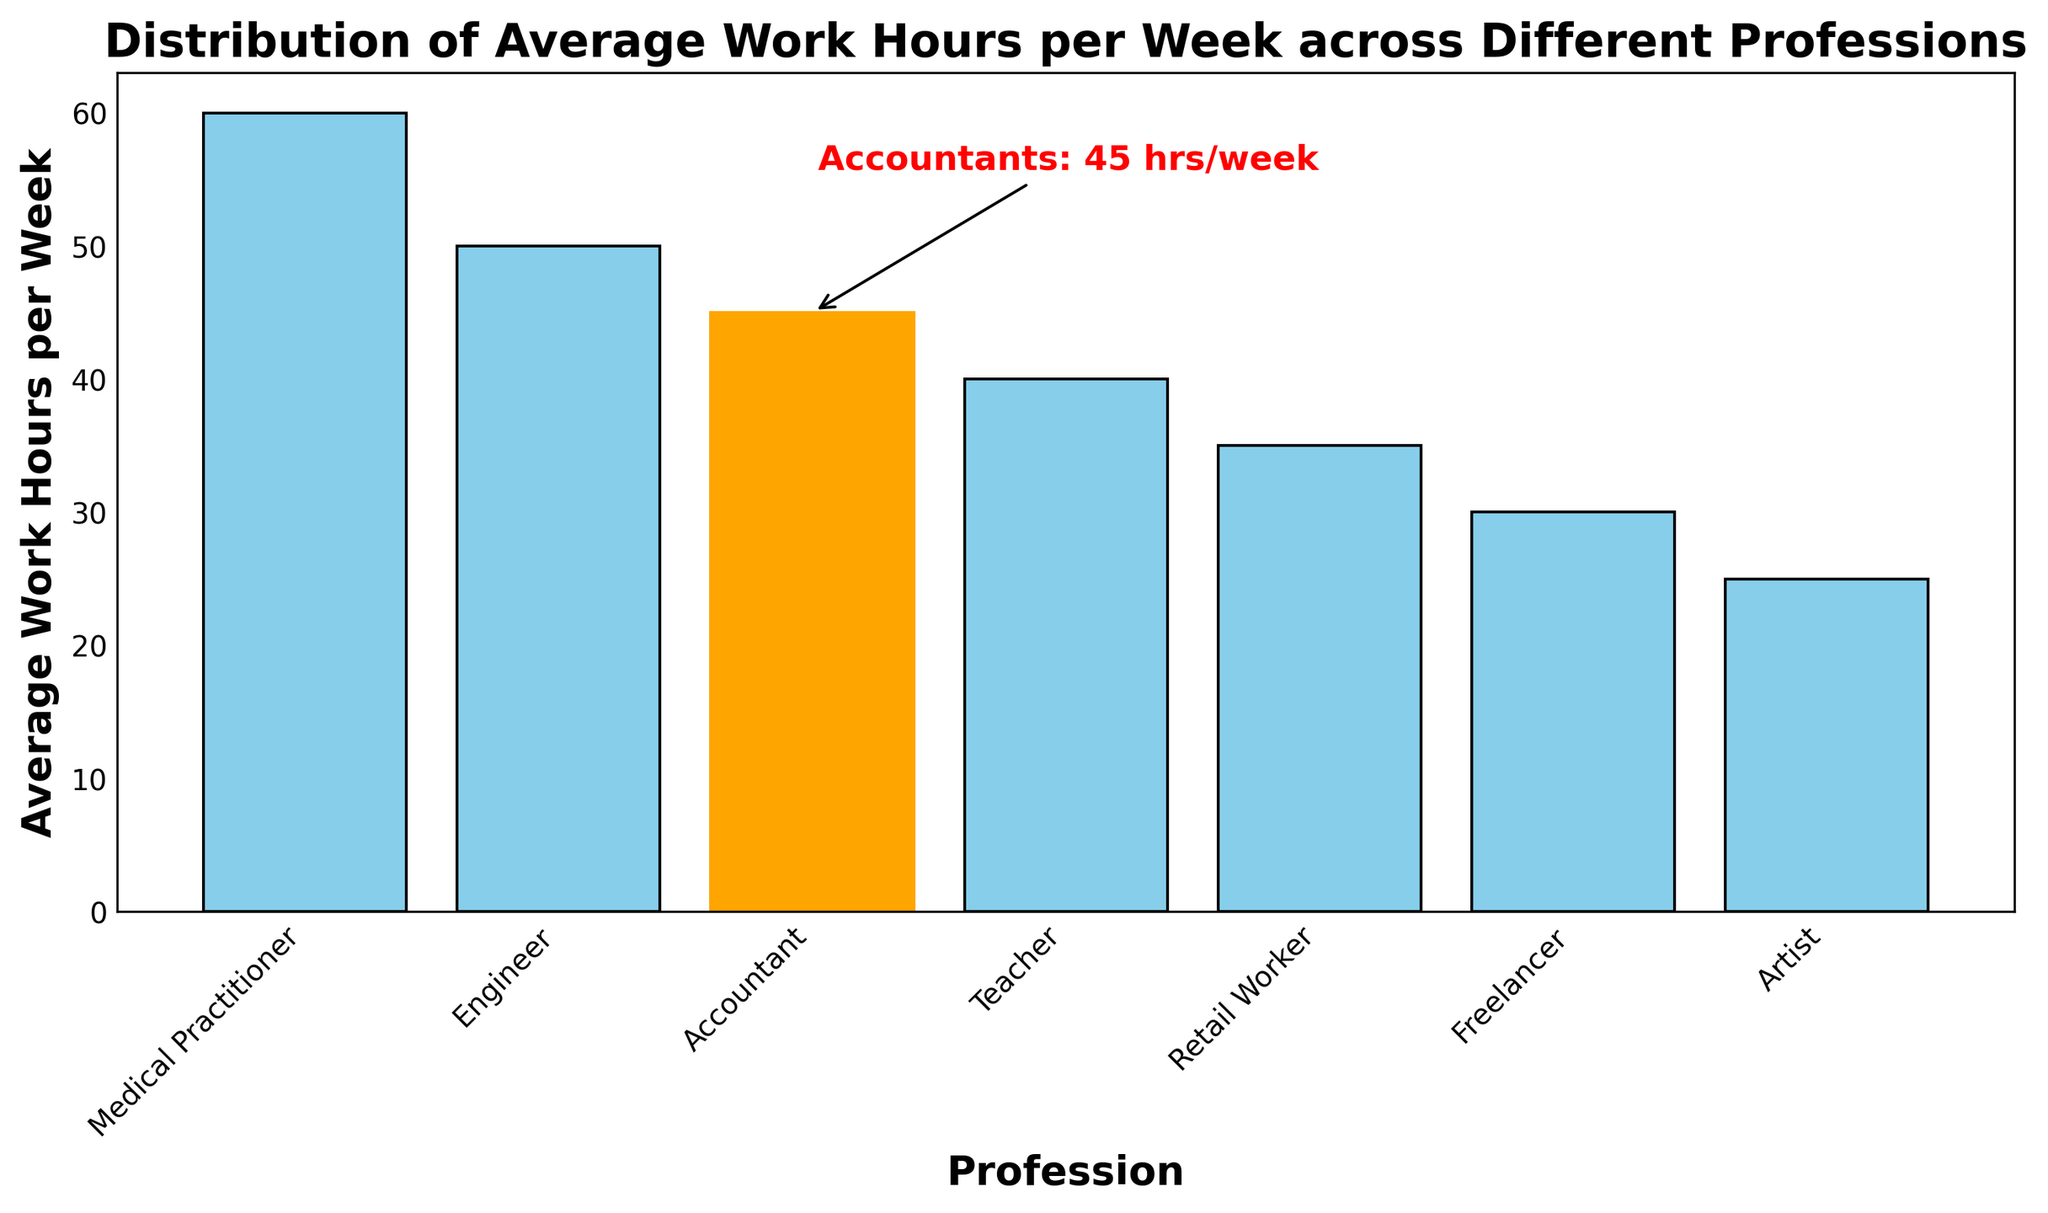Which profession works the least number of hours per week? To determine which profession works the least number of hours per week, look at the bar that has the smallest height. The "Artist" bar has the smallest height, representing 25 average work hours per week.
Answer: Artist Which profession works more hours per week: Engineers or Accountants? To compare the work hours of Engineers and Accountants, refer to the heights of the respective bars. Engineers average 50 hours per week, and Accountants average 45 hours per week. Engineers work more hours than Accountants.
Answer: Engineers How many more hours per week do Medical Practitioners work compared to Freelancers? Identify the average work hours for Medical Practitioners and Freelancers from their respective bars. Medical Practitioners work 60 hours per week, and Freelancers work 30 hours per week. The difference is 60 - 30 = 30 hours.
Answer: 30 hours Which profession has been highlighted in the bar chart? To identify the highlighted profession, look for the bar that is color-coded differently and has an annotation. The "Accountant" bar is highlighted in orange and has a text annotation.
Answer: Accountant What is the total average work hours per week for Teachers and Retail Workers combined? Find the average work hours for Teachers and Retail Workers, which are 40 and 35, respectively. Add these two values together: 40 + 35 = 75 hours.
Answer: 75 hours What inference can you make about the work-life balance of Artists compared to Medical Practitioners based on the chart? Compare the average work hours per week for Artists and Medical Practitioners. Artists work 25 hours per week, whereas Medical Practitioners work 60 hours. This suggests that Artists may have a better work-life balance due to fewer work hours compared to Medical Practitioners.
Answer: Artists may have a better work-life balance Which two professions have the closest average work hours per week, and what are their hours? Compare the average work hours of each profession to find the two that are most similar. Accountants (45 hours) and Teachers (40 hours) have the closest average work hours, differing by only 5 hours.
Answer: Accountants and Teachers, 45 and 40 hours Are there any professions that work exactly 10 more hours per week than Retail Workers? If so, which? Retail Workers work 35 hours per week. Adding 10 hours gives 35 + 10 = 45 hours. The Accountant bar shows 45 hours per week, fitting this criterion.
Answer: Accountant 